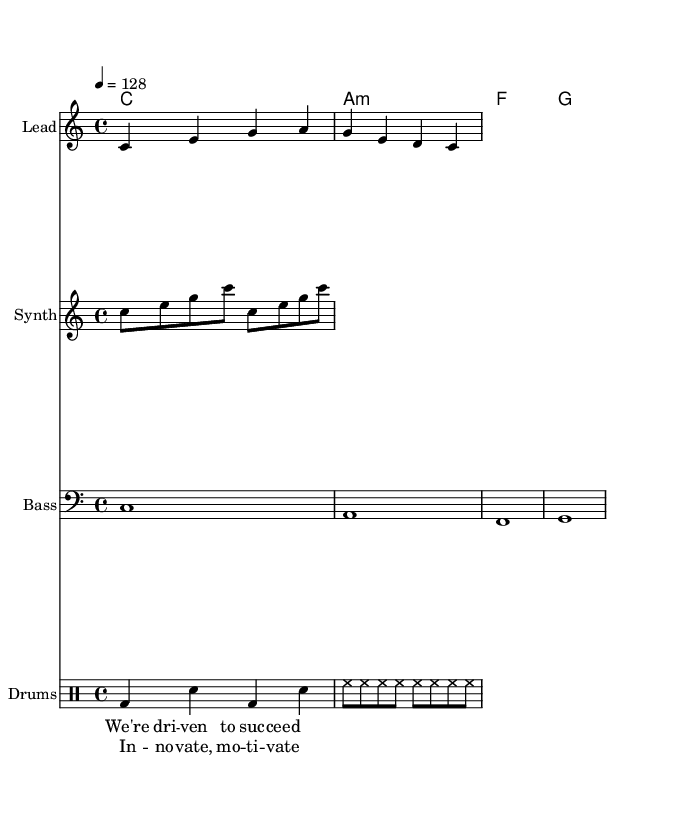What is the key signature of this music? The key signature is C major, which is indicated by the absence of any sharps or flats in the key symbol.
Answer: C major What is the time signature of this piece? The time signature is 4/4, which is shown at the beginning of the staff and means there are four beats in each measure.
Answer: 4/4 What is the tempo marking for this piece? The tempo marking is 128 beats per minute, indicated by the tempo instruction at the beginning of the score.
Answer: 128 How many measures are in the melody? The melody contains four measures, as seen by the notation and spacing on the staff.
Answer: 4 What repeat symbol is present in the synth part? The repeat symbol is "repeat unfold," which indicates that the section should be played twice.
Answer: repeat unfold What is the primary motif in the chorus lyrics? The primary motif in the chorus is "Innovate, motivate," which is both a motivational phrase and the core theme of this dance piece.
Answer: Innovate, motivate How many different instrumental parts are included in the score? There are four different instrumental parts: Lead, Synth, Bass, and Drums, each presented on its own staff.
Answer: 4 